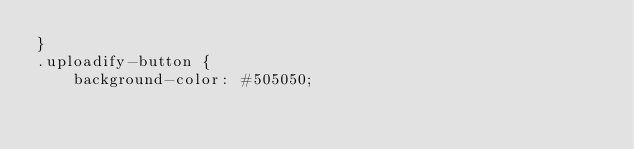<code> <loc_0><loc_0><loc_500><loc_500><_CSS_>}
.uploadify-button {
	background-color: #505050;</code> 